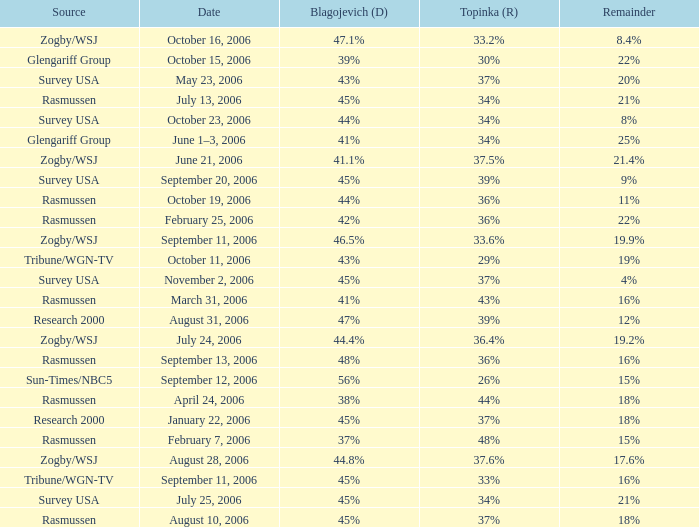Which Blagojevich (D) has a Source of zogby/wsj, and a Topinka (R) of 33.2%? 47.1%. 